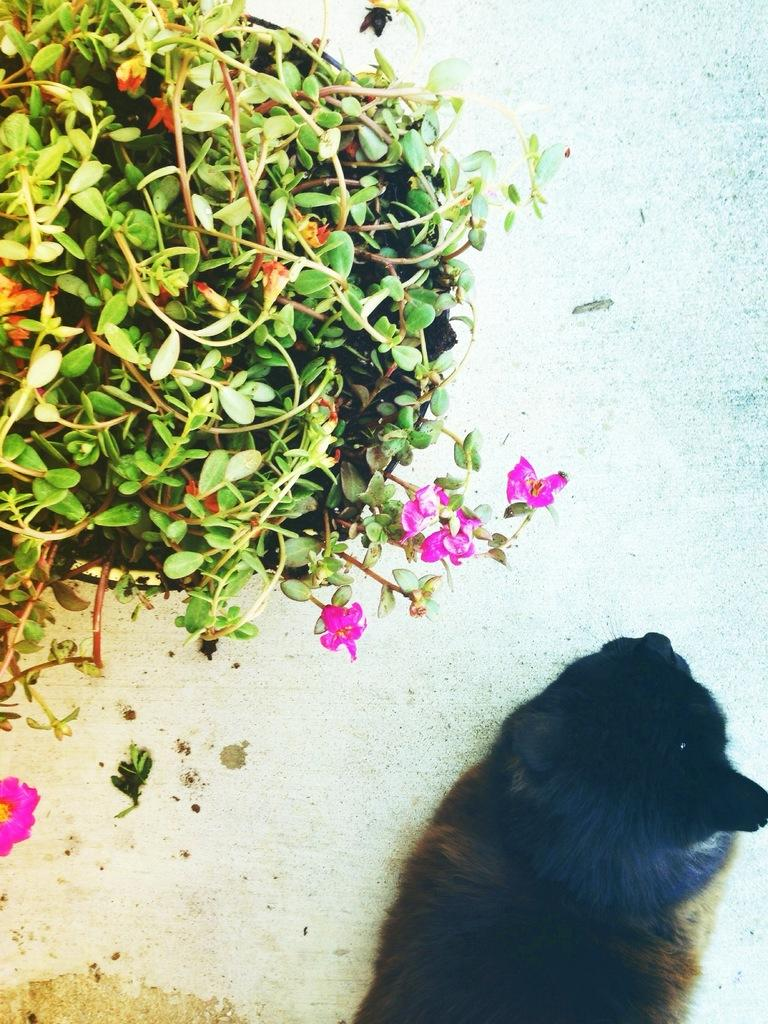What type of living creature is in the image? There is an animal in the image. Where is the animal located in the image? The animal is on the floor. What else can be seen in the image besides the animal? There is a potted plant in the image. What is special about the potted plant? The potted plant has flowers. Can you tell me how many memories the animal has in the image? There is no mention of memories in the image, as it features an animal on the floor and a potted plant with flowers. 